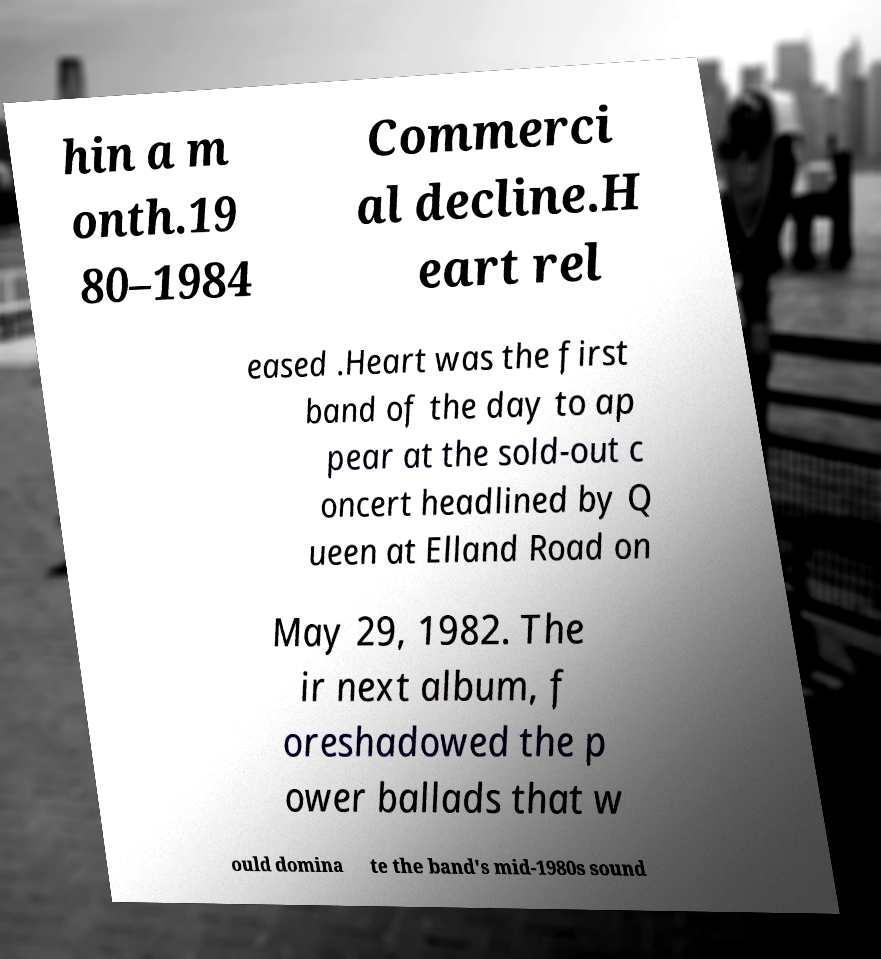For documentation purposes, I need the text within this image transcribed. Could you provide that? hin a m onth.19 80–1984 Commerci al decline.H eart rel eased .Heart was the first band of the day to ap pear at the sold-out c oncert headlined by Q ueen at Elland Road on May 29, 1982. The ir next album, f oreshadowed the p ower ballads that w ould domina te the band's mid-1980s sound 